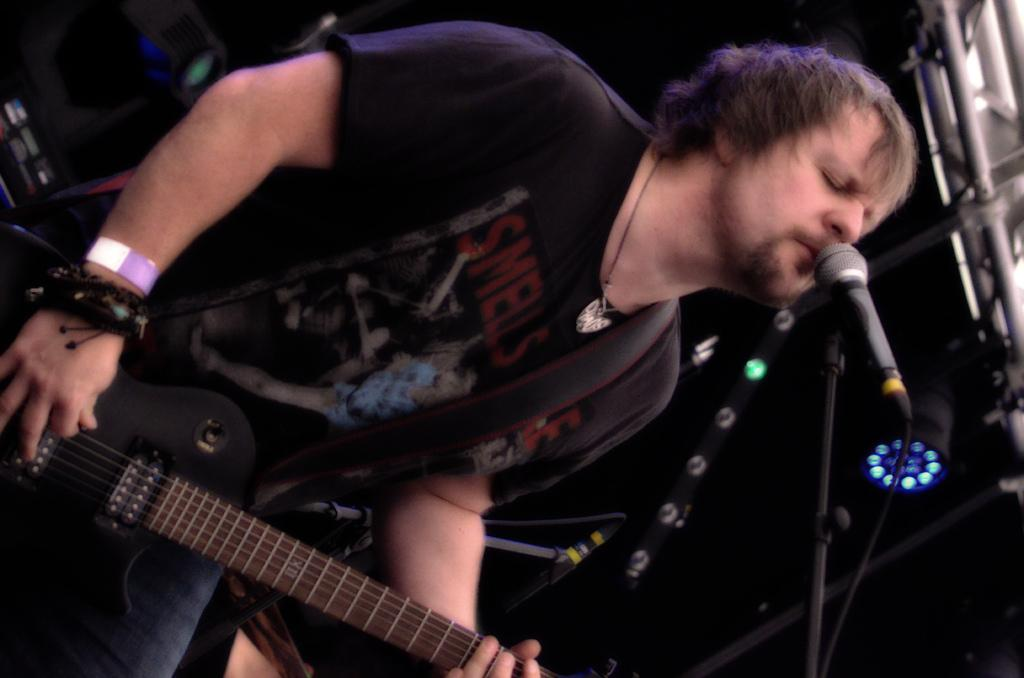What is the man in the image doing? The man is singing in the image. What is the man holding while singing? The man is playing a guitar in the image. What is in front of the man while he is singing and playing the guitar? There is a microphone in front of the man in the image. Can you see any sheep in the garden behind the man? There is no garden or sheep present in the image; it only features a man singing with a guitar and a microphone. 